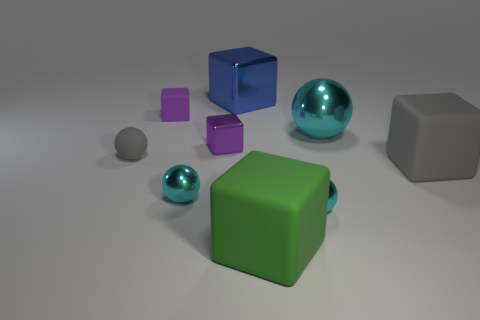Does the cyan ball left of the green object have the same material as the gray sphere?
Keep it short and to the point. No. How big is the blue block?
Make the answer very short. Large. The big thing that is the same color as the small rubber sphere is what shape?
Your answer should be compact. Cube. How many cylinders are small metal things or tiny things?
Keep it short and to the point. 0. Is the number of big blocks that are in front of the tiny gray rubber ball the same as the number of small cyan objects in front of the large green cube?
Your response must be concise. No. The other purple object that is the same shape as the purple matte thing is what size?
Your answer should be very brief. Small. There is a object that is both on the left side of the tiny purple metallic cube and behind the tiny gray rubber sphere; what is its size?
Provide a succinct answer. Small. Are there any small metallic things right of the large blue shiny cube?
Provide a succinct answer. Yes. How many objects are small balls that are on the left side of the small matte cube or big yellow cylinders?
Make the answer very short. 1. How many small purple metal cubes are right of the small rubber thing that is on the left side of the purple matte thing?
Make the answer very short. 1. 